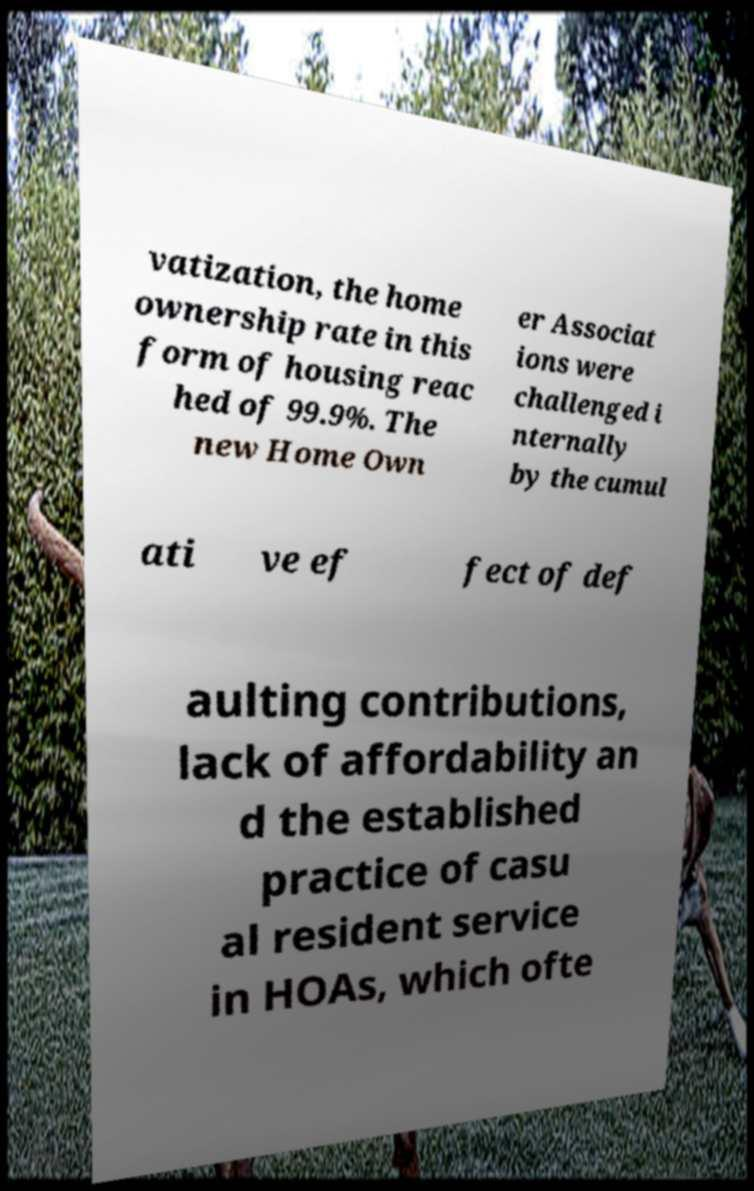Please identify and transcribe the text found in this image. vatization, the home ownership rate in this form of housing reac hed of 99.9%. The new Home Own er Associat ions were challenged i nternally by the cumul ati ve ef fect of def aulting contributions, lack of affordability an d the established practice of casu al resident service in HOAs, which ofte 